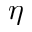<formula> <loc_0><loc_0><loc_500><loc_500>\eta</formula> 